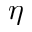<formula> <loc_0><loc_0><loc_500><loc_500>\eta</formula> 